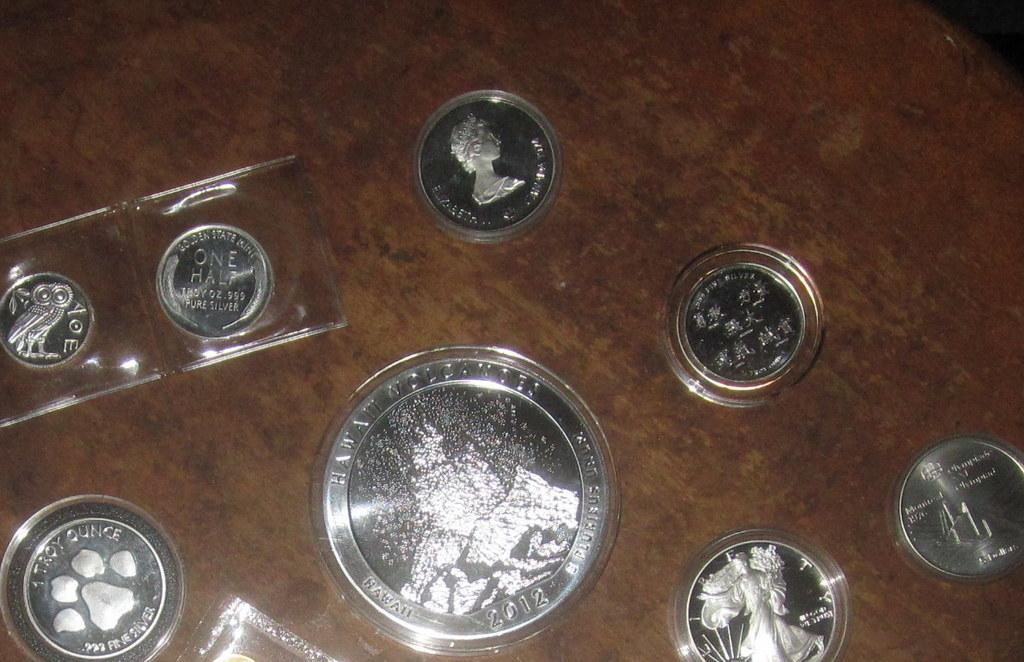What objects are present on the surface in the image? There are coins on the surface in the image. What can be observed about the coins? The coins have different symbols on them. What type of thumb can be seen on the face of the holiday-themed coin in the image? There is no thumb or holiday-themed coin present in the image. 